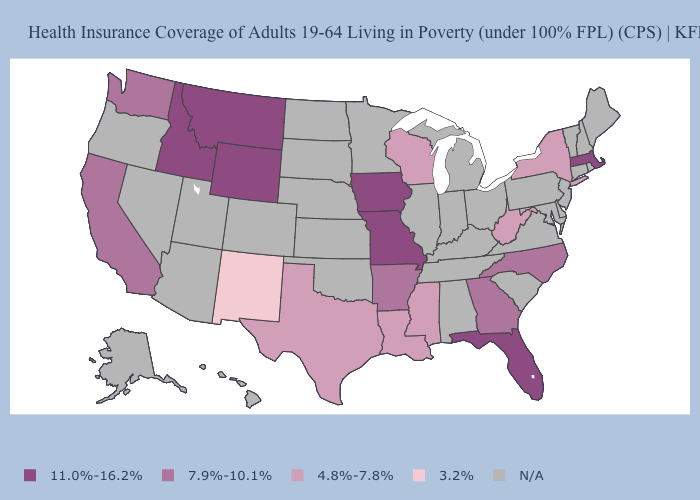Among the states that border Illinois , which have the highest value?
Quick response, please. Iowa, Missouri. What is the value of Wyoming?
Short answer required. 11.0%-16.2%. What is the value of Maine?
Short answer required. N/A. Among the states that border Idaho , which have the highest value?
Short answer required. Montana, Wyoming. What is the lowest value in states that border Tennessee?
Short answer required. 4.8%-7.8%. Which states hav the highest value in the West?
Be succinct. Idaho, Montana, Wyoming. What is the lowest value in the Northeast?
Answer briefly. 4.8%-7.8%. How many symbols are there in the legend?
Short answer required. 5. What is the value of Nevada?
Give a very brief answer. N/A. What is the value of Connecticut?
Quick response, please. N/A. What is the lowest value in states that border New York?
Write a very short answer. 11.0%-16.2%. Name the states that have a value in the range 7.9%-10.1%?
Quick response, please. Arkansas, California, Georgia, North Carolina, Washington. What is the value of Virginia?
Write a very short answer. N/A. Name the states that have a value in the range 4.8%-7.8%?
Be succinct. Louisiana, Mississippi, New York, Texas, West Virginia, Wisconsin. 